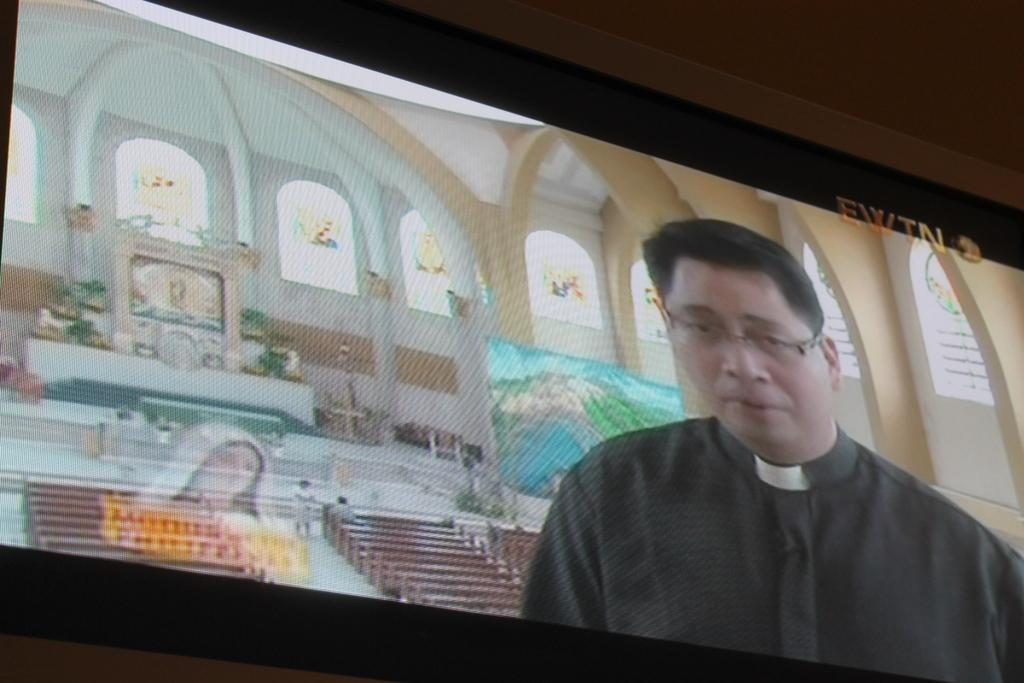What electronic device can be seen in the image? There is a television in the image. What is being displayed on the television? A person is visible on the television. What type of seating is available in the image? There are benches in the image. What type of artwork is present in the image? Sculptures are present in the image. What type of glasswork is visible in the image? Stained glasses are visible in the image. What type of suit is the person on the television wearing? There is no information about the person's clothing in the image, as it only shows a person on the television. What type of toys can be seen on the benches in the image? There are no toys present in the image; it features a television, benches, sculptures, and stained glasses. 